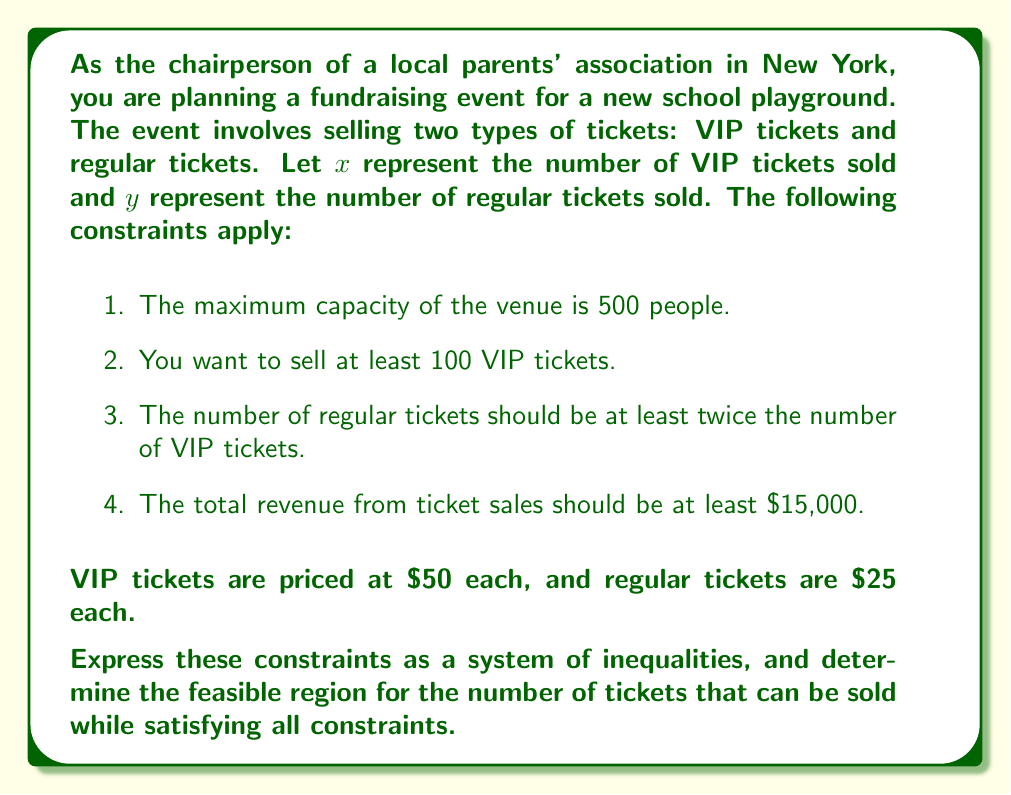Solve this math problem. Let's express each constraint as an inequality:

1. Maximum capacity: $x + y \leq 500$
2. Minimum VIP tickets: $x \geq 100$
3. Regular tickets at least twice VIP tickets: $y \geq 2x$
4. Minimum total revenue: $50x + 25y \geq 15000$

To find the feasible region, we need to graph these inequalities:

1. $x + y = 500$ is a straight line. The region below this line satisfies the inequality.
2. $x = 100$ is a vertical line. The region to the right of this line satisfies the inequality.
3. $y = 2x$ is a straight line through the origin. The region above this line satisfies the inequality.
4. $50x + 25y = 15000$ can be simplified to $2x + y = 600$. This is a straight line, and the region above this line satisfies the inequality.

The feasible region is the area that satisfies all four inequalities simultaneously. It is bounded by the lines $x = 100$, $y = 2x$, and $2x + y = 600$, and lies below the line $x + y = 500$.

To find the vertices of this region, we solve the equations of the intersecting lines:

- $x = 100$ and $y = 2x$: $(100, 200)$
- $x = 100$ and $2x + y = 600$: $(100, 400)$
- $y = 2x$ and $2x + y = 600$: $(150, 300)$

The feasible region is the triangle formed by these three points.
Answer: The system of inequalities representing the constraints is:

$$
\begin{cases}
x + y \leq 500 \\
x \geq 100 \\
y \geq 2x \\
2x + y \geq 600
\end{cases}
$$

The feasible region is a triangle with vertices at $(100, 200)$, $(100, 400)$, and $(150, 300)$. 